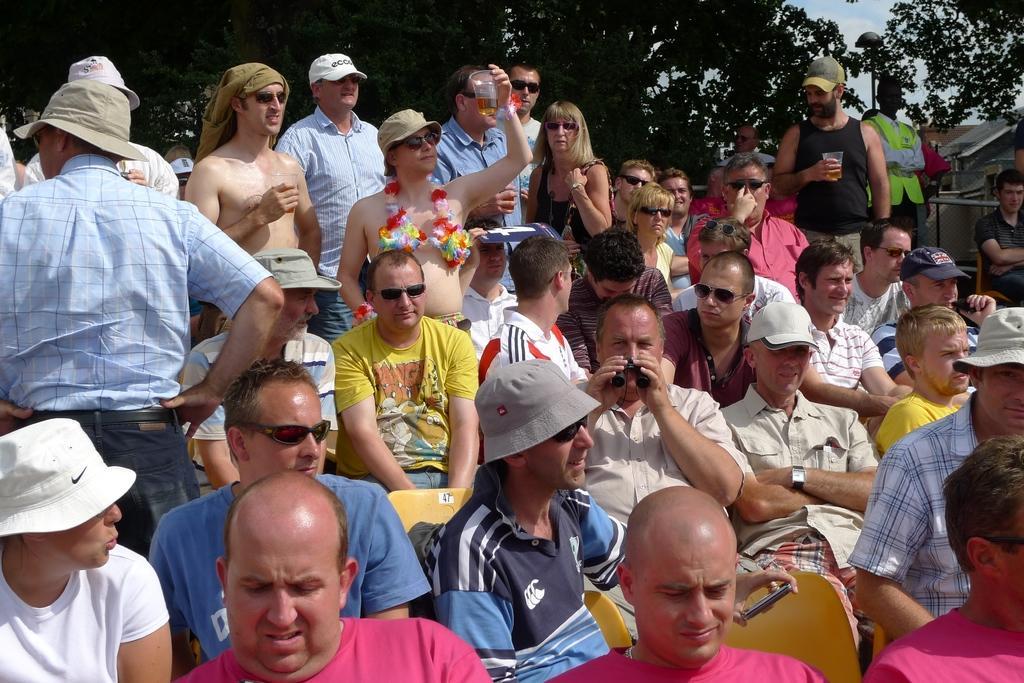Could you give a brief overview of what you see in this image? In this image there are people sitting on chairs and few are standing, in the background there are trees. 